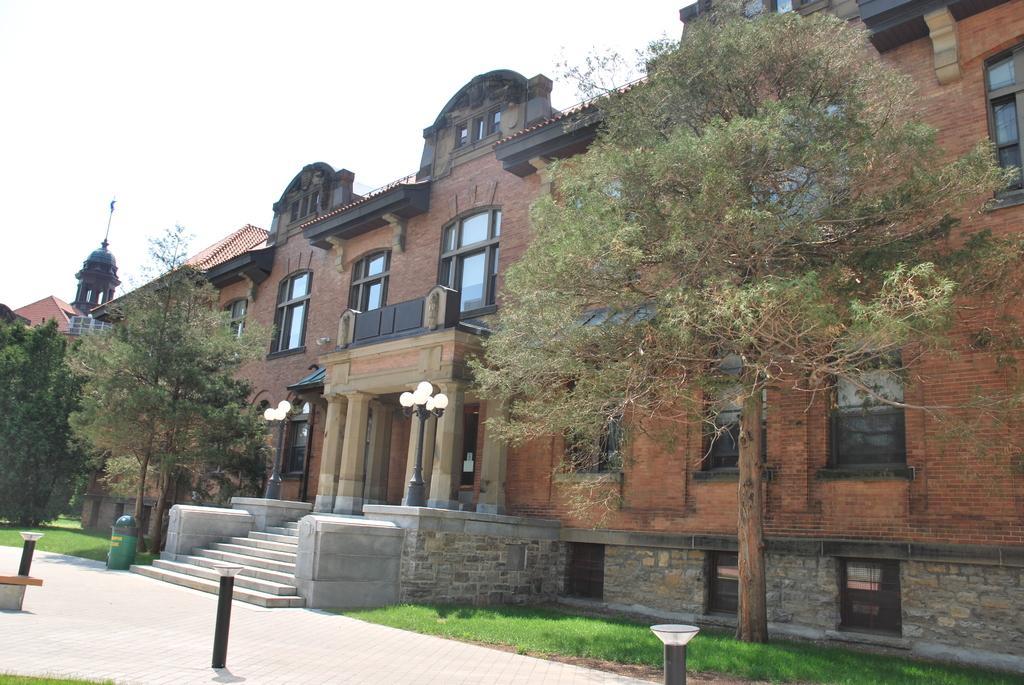Can you describe this image briefly? In this image we can see buildings, windows, there are light poles, there is a dustbin, there are trees, grass, also we can see the sky. 